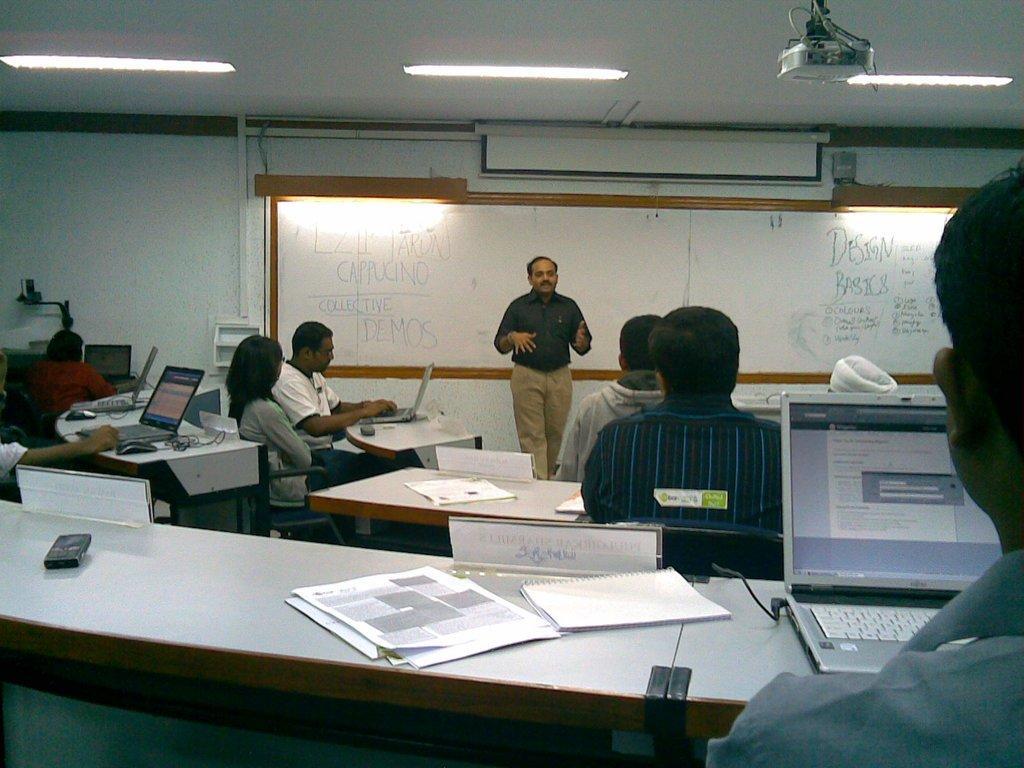In one or two sentences, can you explain what this image depicts? Here we can see a few people sitting on a chair and they are working on a laptop. There is a person standing in the center and he is explaining something to this people. This is a board and this is roof with lightning arrangement. This is a projector and this is a screen. 